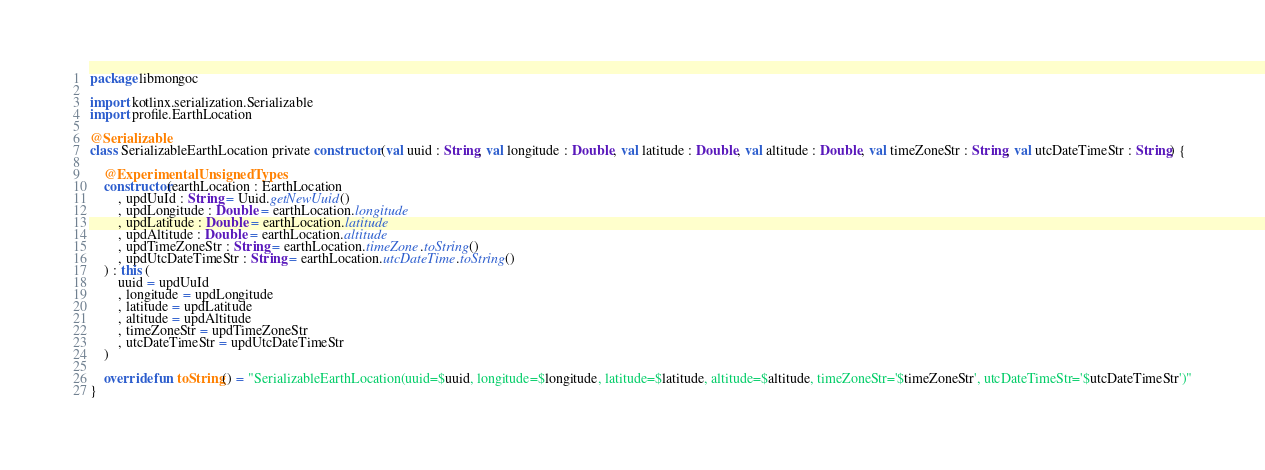<code> <loc_0><loc_0><loc_500><loc_500><_Kotlin_>package libmongoc

import kotlinx.serialization.Serializable
import profile.EarthLocation

@Serializable
class SerializableEarthLocation private constructor (val uuid : String, val longitude : Double, val latitude : Double, val altitude : Double, val timeZoneStr : String, val utcDateTimeStr : String) {

    @ExperimentalUnsignedTypes
    constructor(earthLocation : EarthLocation
        , updUuId : String = Uuid.getNewUuid()
        , updLongitude : Double = earthLocation.longitude
        , updLatitude : Double = earthLocation.latitude
        , updAltitude : Double = earthLocation.altitude
        , updTimeZoneStr : String = earthLocation.timeZone.toString()
        , updUtcDateTimeStr : String = earthLocation.utcDateTime.toString()
    ) : this (
        uuid = updUuId
        , longitude = updLongitude
        , latitude = updLatitude
        , altitude = updAltitude
        , timeZoneStr = updTimeZoneStr
        , utcDateTimeStr = updUtcDateTimeStr
    )

    override fun toString() = "SerializableEarthLocation(uuid=$uuid, longitude=$longitude, latitude=$latitude, altitude=$altitude, timeZoneStr='$timeZoneStr', utcDateTimeStr='$utcDateTimeStr')"
}


</code> 